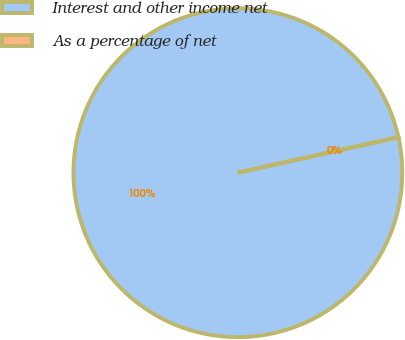Convert chart to OTSL. <chart><loc_0><loc_0><loc_500><loc_500><pie_chart><fcel>Interest and other income net<fcel>As a percentage of net<nl><fcel>100.0%<fcel>0.0%<nl></chart> 